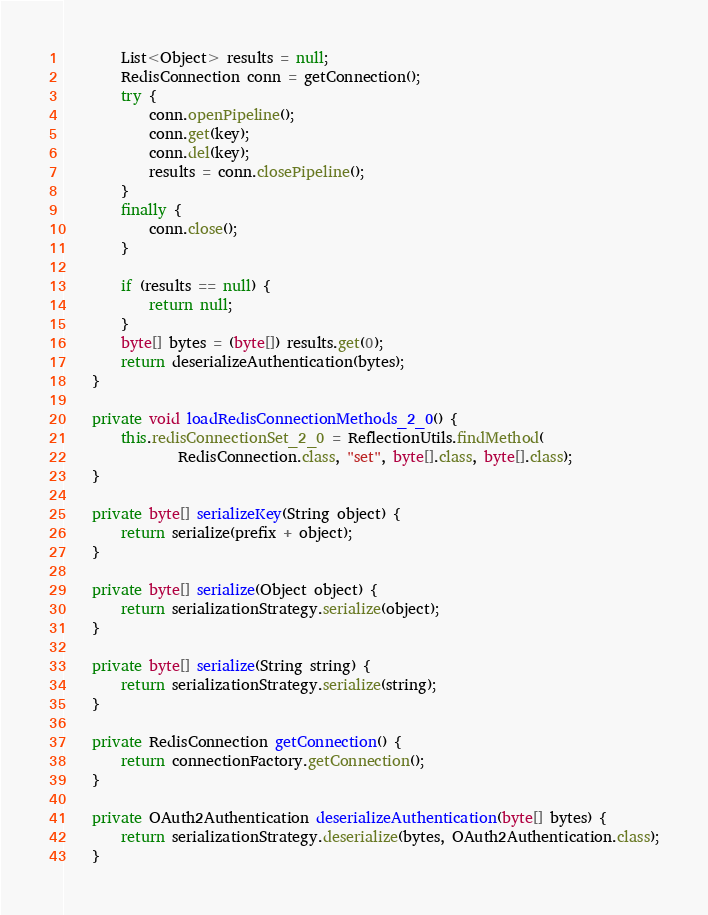<code> <loc_0><loc_0><loc_500><loc_500><_Java_>
		List<Object> results = null;
		RedisConnection conn = getConnection();
		try {
			conn.openPipeline();
			conn.get(key);
			conn.del(key);
			results = conn.closePipeline();
		}
		finally {
			conn.close();
		}

		if (results == null) {
			return null;
		}
		byte[] bytes = (byte[]) results.get(0);
		return deserializeAuthentication(bytes);
	}

	private void loadRedisConnectionMethods_2_0() {
		this.redisConnectionSet_2_0 = ReflectionUtils.findMethod(
				RedisConnection.class, "set", byte[].class, byte[].class);
	}

	private byte[] serializeKey(String object) {
		return serialize(prefix + object);
	}

	private byte[] serialize(Object object) {
		return serializationStrategy.serialize(object);
	}

	private byte[] serialize(String string) {
		return serializationStrategy.serialize(string);
	}

	private RedisConnection getConnection() {
		return connectionFactory.getConnection();
	}

	private OAuth2Authentication deserializeAuthentication(byte[] bytes) {
		return serializationStrategy.deserialize(bytes, OAuth2Authentication.class);
	}
</code> 